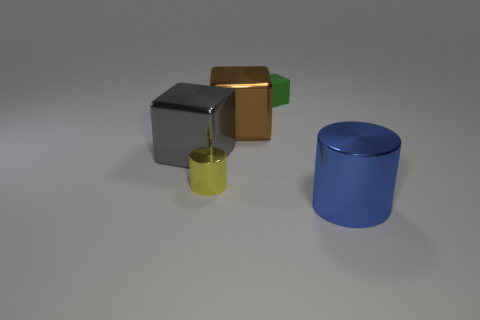Are there fewer large metal objects behind the large gray cube than things that are to the left of the matte block?
Offer a very short reply. Yes. How many large things are metallic things or green metallic cylinders?
Ensure brevity in your answer.  3. There is a large metallic object to the right of the small matte object; is it the same shape as the tiny thing left of the small rubber cube?
Your answer should be very brief. Yes. What size is the shiny cylinder right of the metallic cylinder that is to the left of the shiny thing that is on the right side of the matte block?
Give a very brief answer. Large. There is a cube in front of the brown thing; how big is it?
Ensure brevity in your answer.  Large. There is a large blue cylinder in front of the gray block; what is it made of?
Offer a very short reply. Metal. How many yellow things are either small cylinders or tiny cubes?
Your answer should be compact. 1. Do the large blue cylinder and the big block to the right of the yellow metallic cylinder have the same material?
Give a very brief answer. Yes. Is the number of blue metal cylinders that are to the left of the yellow object the same as the number of large brown shiny things that are on the right side of the large brown cube?
Provide a succinct answer. Yes. Do the gray shiny object and the cylinder that is left of the large brown cube have the same size?
Give a very brief answer. No. 